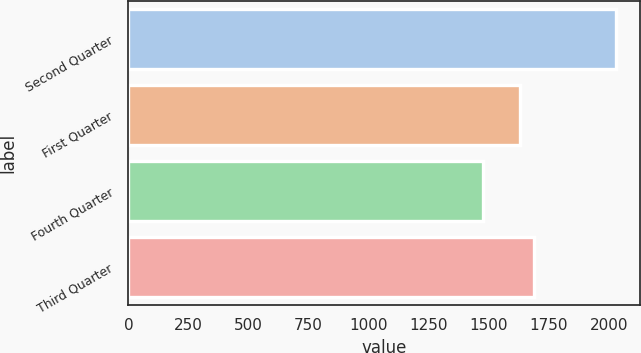Convert chart to OTSL. <chart><loc_0><loc_0><loc_500><loc_500><bar_chart><fcel>Second Quarter<fcel>First Quarter<fcel>Fourth Quarter<fcel>Third Quarter<nl><fcel>2028.99<fcel>1631.78<fcel>1478.04<fcel>1686.88<nl></chart> 